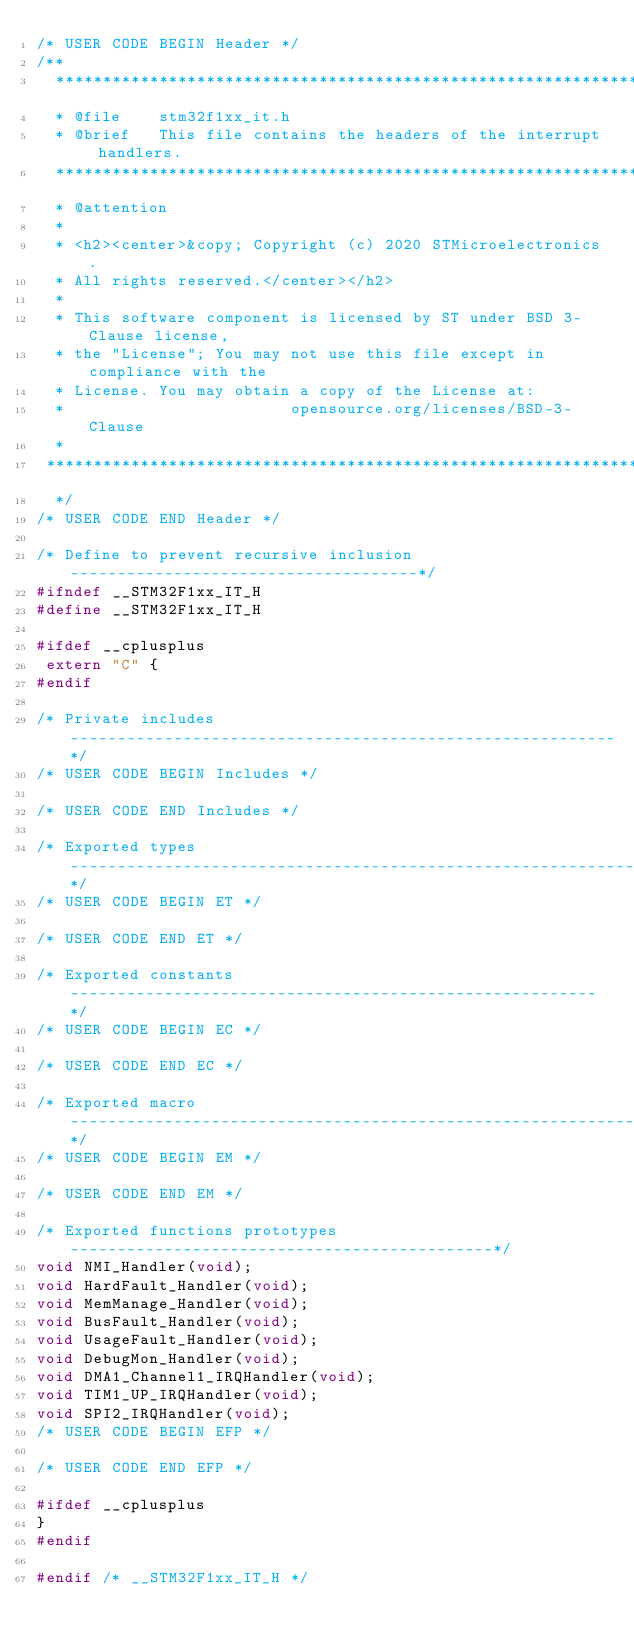<code> <loc_0><loc_0><loc_500><loc_500><_C_>/* USER CODE BEGIN Header */
/**
  ******************************************************************************
  * @file    stm32f1xx_it.h
  * @brief   This file contains the headers of the interrupt handlers.
  ******************************************************************************
  * @attention
  *
  * <h2><center>&copy; Copyright (c) 2020 STMicroelectronics.
  * All rights reserved.</center></h2>
  *
  * This software component is licensed by ST under BSD 3-Clause license,
  * the "License"; You may not use this file except in compliance with the
  * License. You may obtain a copy of the License at:
  *                        opensource.org/licenses/BSD-3-Clause
  *
 ******************************************************************************
  */
/* USER CODE END Header */

/* Define to prevent recursive inclusion -------------------------------------*/
#ifndef __STM32F1xx_IT_H
#define __STM32F1xx_IT_H

#ifdef __cplusplus
 extern "C" {
#endif

/* Private includes ----------------------------------------------------------*/
/* USER CODE BEGIN Includes */

/* USER CODE END Includes */

/* Exported types ------------------------------------------------------------*/
/* USER CODE BEGIN ET */

/* USER CODE END ET */

/* Exported constants --------------------------------------------------------*/
/* USER CODE BEGIN EC */

/* USER CODE END EC */

/* Exported macro ------------------------------------------------------------*/
/* USER CODE BEGIN EM */

/* USER CODE END EM */

/* Exported functions prototypes ---------------------------------------------*/
void NMI_Handler(void);
void HardFault_Handler(void);
void MemManage_Handler(void);
void BusFault_Handler(void);
void UsageFault_Handler(void);
void DebugMon_Handler(void);
void DMA1_Channel1_IRQHandler(void);
void TIM1_UP_IRQHandler(void);
void SPI2_IRQHandler(void);
/* USER CODE BEGIN EFP */

/* USER CODE END EFP */

#ifdef __cplusplus
}
#endif

#endif /* __STM32F1xx_IT_H */
</code> 